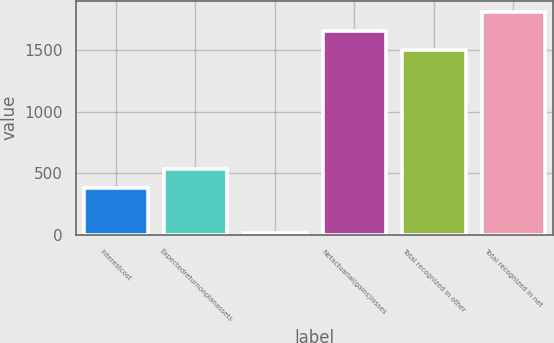<chart> <loc_0><loc_0><loc_500><loc_500><bar_chart><fcel>Interestcost<fcel>Expectedreturnonplanassets<fcel>Unnamed: 2<fcel>Netactuarial(gains)losses<fcel>Total recognized in other<fcel>Total recognized in net<nl><fcel>379<fcel>534.4<fcel>15<fcel>1658.4<fcel>1503<fcel>1813.8<nl></chart> 